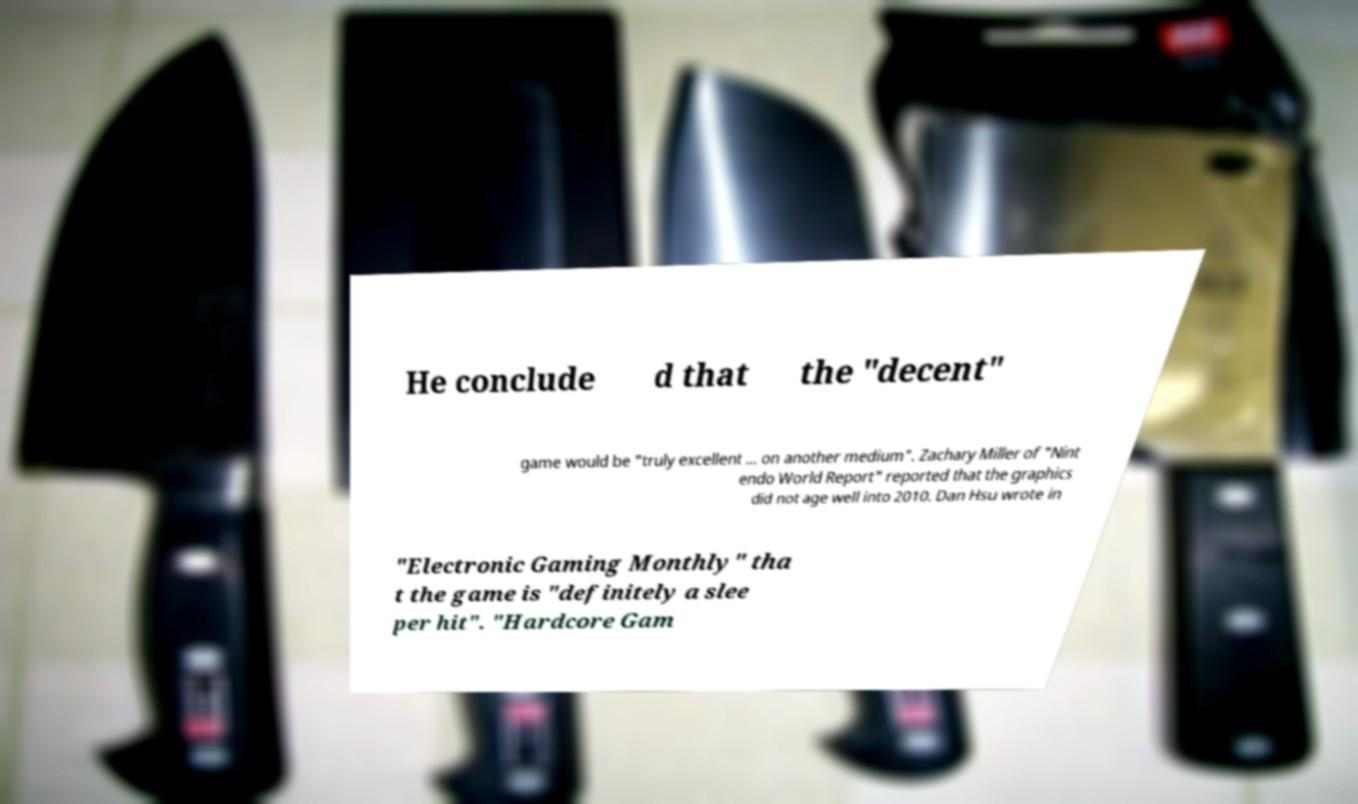Can you accurately transcribe the text from the provided image for me? He conclude d that the "decent" game would be "truly excellent ... on another medium". Zachary Miller of "Nint endo World Report" reported that the graphics did not age well into 2010. Dan Hsu wrote in "Electronic Gaming Monthly" tha t the game is "definitely a slee per hit". "Hardcore Gam 